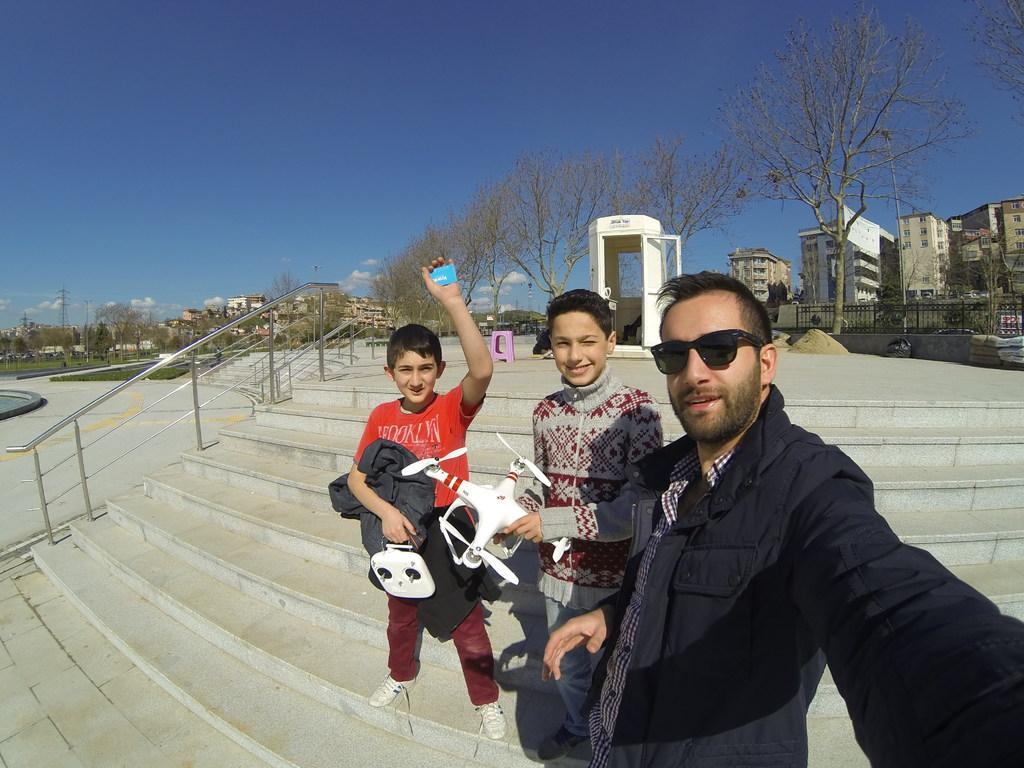Describe this image in one or two sentences. In the foreground of the I can see a man and two boys. There is a man on the right side is wearing a jacket and there is a smile on his face. I can see a boy holding an aircraft toy in his hands. There is another boy holding a jacket and remote control device in his hands. I can see the staircase and stainless steel pole. In the background, I can see the buildings and deciduous trees. I can see the electric poles. There are clouds in the sky. 